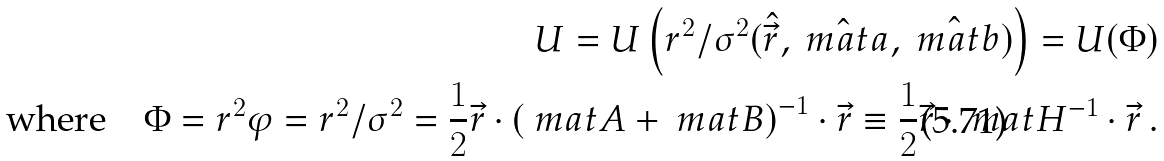<formula> <loc_0><loc_0><loc_500><loc_500>U = U \left ( r ^ { 2 } / \sigma ^ { 2 } ( \hat { \vec { r } } , \hat { \ m a t { a } } , \hat { \ m a t { b } } ) \right ) = U ( \Phi ) \\ \text {where} \quad \Phi = r ^ { 2 } \varphi = r ^ { 2 } / \sigma ^ { 2 } = \frac { 1 } { 2 } \vec { r } \cdot \left ( \ m a t { A } + \ m a t { B } \right ) ^ { - 1 } \cdot \vec { r } \equiv \frac { 1 } { 2 } \vec { r } \cdot \ m a t { H } ^ { - 1 } \cdot \vec { r } \, .</formula> 